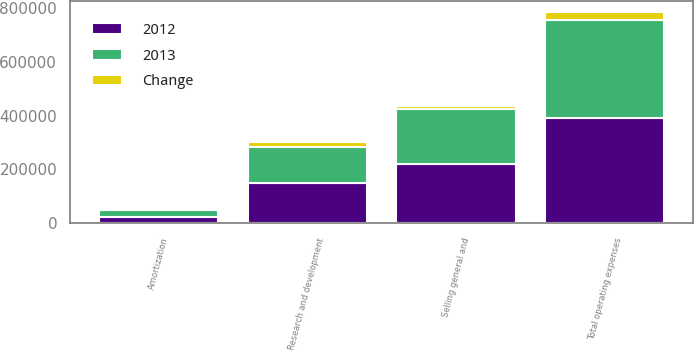Convert chart to OTSL. <chart><loc_0><loc_0><loc_500><loc_500><stacked_bar_chart><ecel><fcel>Selling general and<fcel>Research and development<fcel>Amortization<fcel>Total operating expenses<nl><fcel>2012<fcel>218907<fcel>151439<fcel>22359<fcel>392705<nl><fcel>2013<fcel>205178<fcel>132628<fcel>26443<fcel>364249<nl><fcel>Change<fcel>13729<fcel>18811<fcel>4084<fcel>28456<nl></chart> 